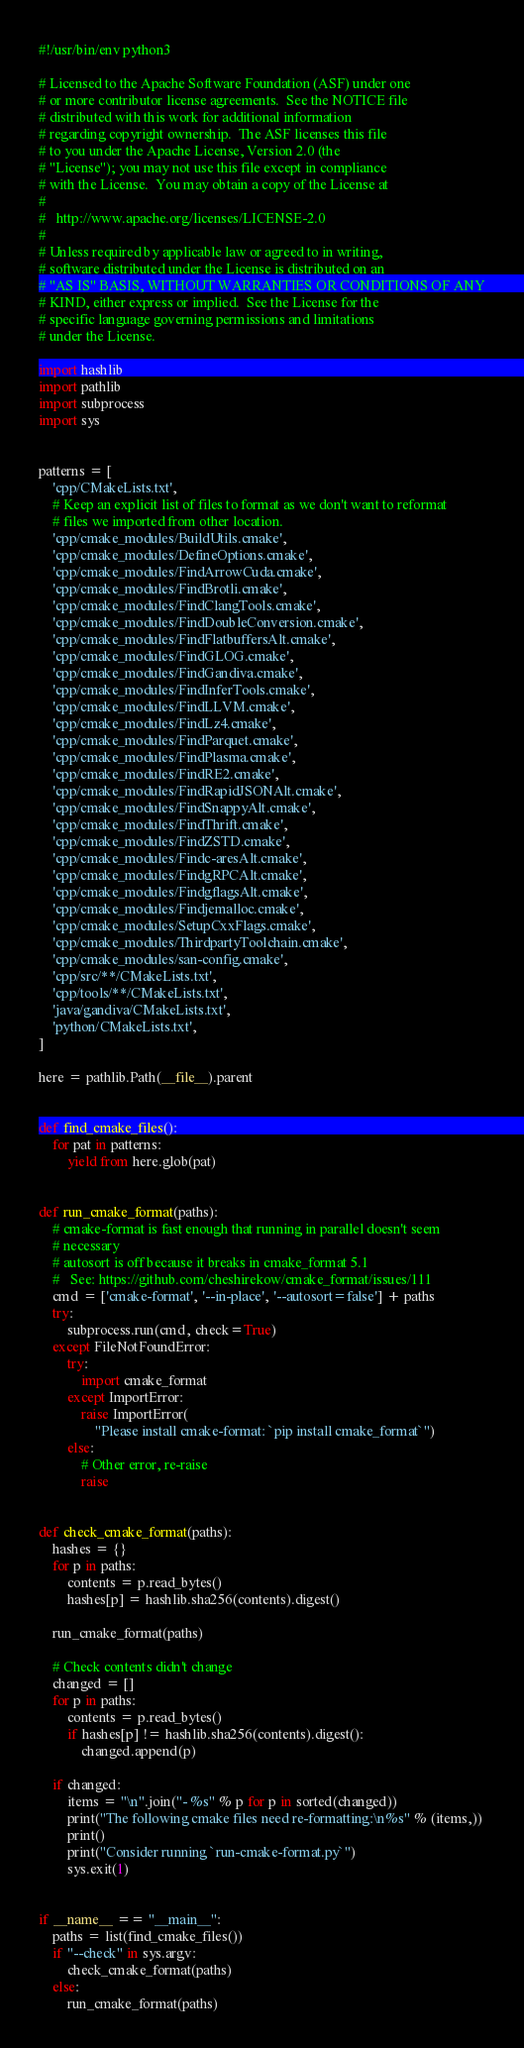Convert code to text. <code><loc_0><loc_0><loc_500><loc_500><_Python_>#!/usr/bin/env python3

# Licensed to the Apache Software Foundation (ASF) under one
# or more contributor license agreements.  See the NOTICE file
# distributed with this work for additional information
# regarding copyright ownership.  The ASF licenses this file
# to you under the Apache License, Version 2.0 (the
# "License"); you may not use this file except in compliance
# with the License.  You may obtain a copy of the License at
#
#   http://www.apache.org/licenses/LICENSE-2.0
#
# Unless required by applicable law or agreed to in writing,
# software distributed under the License is distributed on an
# "AS IS" BASIS, WITHOUT WARRANTIES OR CONDITIONS OF ANY
# KIND, either express or implied.  See the License for the
# specific language governing permissions and limitations
# under the License.

import hashlib
import pathlib
import subprocess
import sys


patterns = [
    'cpp/CMakeLists.txt',
    # Keep an explicit list of files to format as we don't want to reformat
    # files we imported from other location.
    'cpp/cmake_modules/BuildUtils.cmake',
    'cpp/cmake_modules/DefineOptions.cmake',
    'cpp/cmake_modules/FindArrowCuda.cmake',
    'cpp/cmake_modules/FindBrotli.cmake',
    'cpp/cmake_modules/FindClangTools.cmake',
    'cpp/cmake_modules/FindDoubleConversion.cmake',
    'cpp/cmake_modules/FindFlatbuffersAlt.cmake',
    'cpp/cmake_modules/FindGLOG.cmake',
    'cpp/cmake_modules/FindGandiva.cmake',
    'cpp/cmake_modules/FindInferTools.cmake',
    'cpp/cmake_modules/FindLLVM.cmake',
    'cpp/cmake_modules/FindLz4.cmake',
    'cpp/cmake_modules/FindParquet.cmake',
    'cpp/cmake_modules/FindPlasma.cmake',
    'cpp/cmake_modules/FindRE2.cmake',
    'cpp/cmake_modules/FindRapidJSONAlt.cmake',
    'cpp/cmake_modules/FindSnappyAlt.cmake',
    'cpp/cmake_modules/FindThrift.cmake',
    'cpp/cmake_modules/FindZSTD.cmake',
    'cpp/cmake_modules/Findc-aresAlt.cmake',
    'cpp/cmake_modules/FindgRPCAlt.cmake',
    'cpp/cmake_modules/FindgflagsAlt.cmake',
    'cpp/cmake_modules/Findjemalloc.cmake',
    'cpp/cmake_modules/SetupCxxFlags.cmake',
    'cpp/cmake_modules/ThirdpartyToolchain.cmake',
    'cpp/cmake_modules/san-config.cmake',
    'cpp/src/**/CMakeLists.txt',
    'cpp/tools/**/CMakeLists.txt',
    'java/gandiva/CMakeLists.txt',
    'python/CMakeLists.txt',
]

here = pathlib.Path(__file__).parent


def find_cmake_files():
    for pat in patterns:
        yield from here.glob(pat)


def run_cmake_format(paths):
    # cmake-format is fast enough that running in parallel doesn't seem
    # necessary
    # autosort is off because it breaks in cmake_format 5.1
    #   See: https://github.com/cheshirekow/cmake_format/issues/111
    cmd = ['cmake-format', '--in-place', '--autosort=false'] + paths
    try:
        subprocess.run(cmd, check=True)
    except FileNotFoundError:
        try:
            import cmake_format
        except ImportError:
            raise ImportError(
                "Please install cmake-format: `pip install cmake_format`")
        else:
            # Other error, re-raise
            raise


def check_cmake_format(paths):
    hashes = {}
    for p in paths:
        contents = p.read_bytes()
        hashes[p] = hashlib.sha256(contents).digest()

    run_cmake_format(paths)

    # Check contents didn't change
    changed = []
    for p in paths:
        contents = p.read_bytes()
        if hashes[p] != hashlib.sha256(contents).digest():
            changed.append(p)

    if changed:
        items = "\n".join("- %s" % p for p in sorted(changed))
        print("The following cmake files need re-formatting:\n%s" % (items,))
        print()
        print("Consider running `run-cmake-format.py`")
        sys.exit(1)


if __name__ == "__main__":
    paths = list(find_cmake_files())
    if "--check" in sys.argv:
        check_cmake_format(paths)
    else:
        run_cmake_format(paths)
</code> 